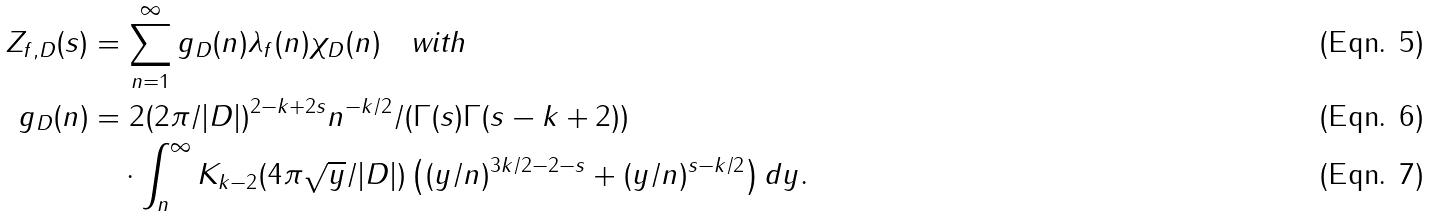Convert formula to latex. <formula><loc_0><loc_0><loc_500><loc_500>Z _ { f , D } ( s ) & = \sum _ { n = 1 } ^ { \infty } g _ { D } ( n ) \lambda _ { f } ( n ) \chi _ { D } ( n ) \quad \text {with} \\ g _ { D } ( n ) & = 2 ( 2 \pi / | D | ) ^ { 2 - k + 2 s } n ^ { - k / 2 } / ( \Gamma ( s ) \Gamma ( s - k + 2 ) ) \\ & \quad \cdot \int _ { n } ^ { \infty } K _ { k - 2 } ( 4 \pi \sqrt { y } / | D | ) \left ( ( y / n ) ^ { 3 k / 2 - 2 - s } + ( y / n ) ^ { s - k / 2 } \right ) d y .</formula> 